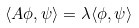<formula> <loc_0><loc_0><loc_500><loc_500>\langle A \phi , \psi \rangle = \lambda \langle \phi , \psi \rangle</formula> 